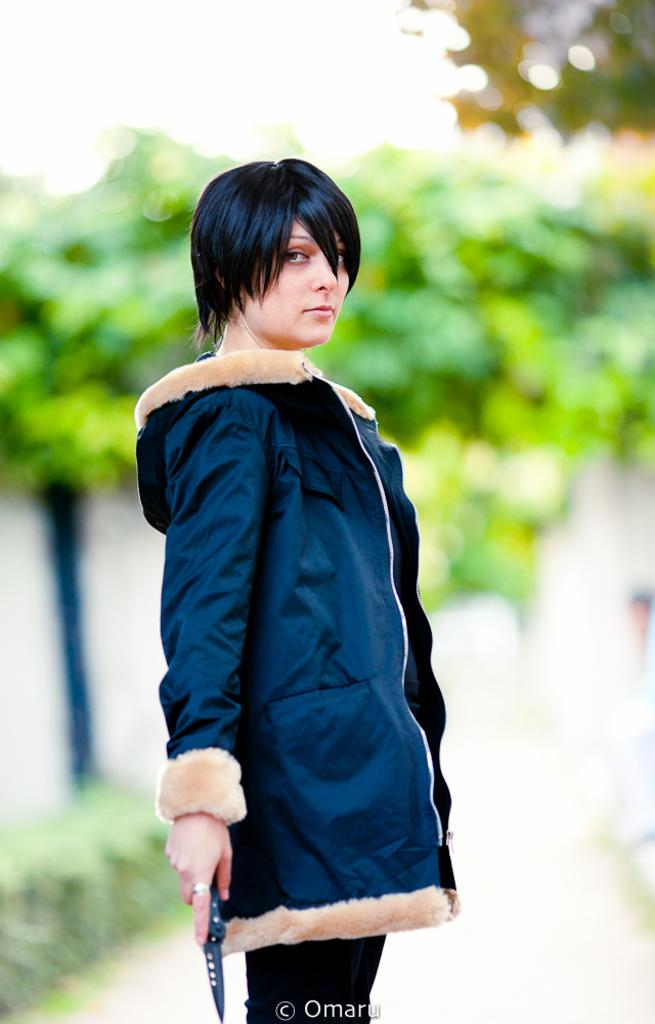Who is present in the image? There is a lady in the image. What is the lady holding in the image? The lady is holding an object. What type of natural environment is depicted in the image? There are many trees and plants in the image. What man-made object can be seen in the image? There is a pole in the image. What type of wood is the woman holding in the image? There is no woman present in the image, and no wood is visible. 